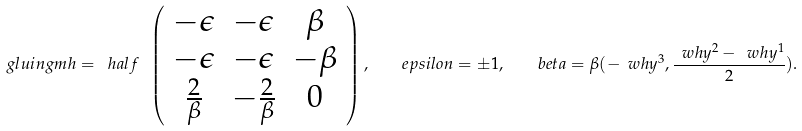<formula> <loc_0><loc_0><loc_500><loc_500>\ g l u i n g m h = \ h a l f \ \left ( \begin{array} { c c c } - { \epsilon } & - { \epsilon } & { \beta } \\ - { \epsilon } & - { \epsilon } & - { \beta } \\ \frac { 2 } { \beta } & - \frac { 2 } { \beta } & 0 \end{array} \right ) , \quad e p s i l o n = \pm 1 , \quad b e t a = \beta ( - \ w h y ^ { 3 } , \frac { \ w h y ^ { 2 } - \ w h y ^ { 1 } } { 2 } ) .</formula> 